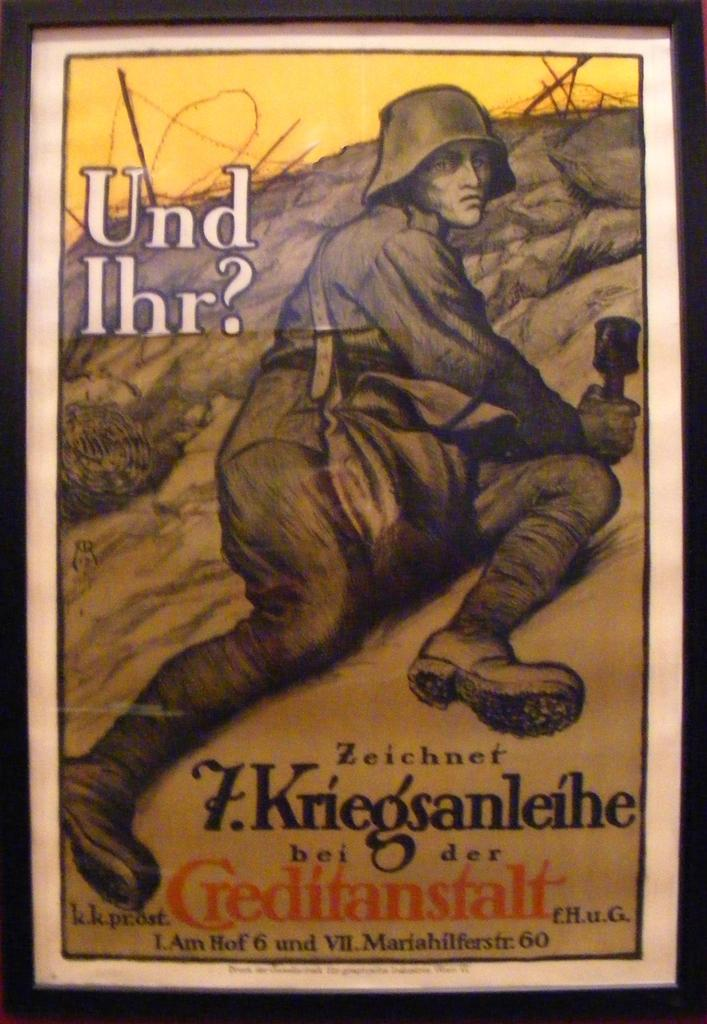<image>
Give a short and clear explanation of the subsequent image. The cover of the German novel "Und Ihr?" with a soldier on its cover. 